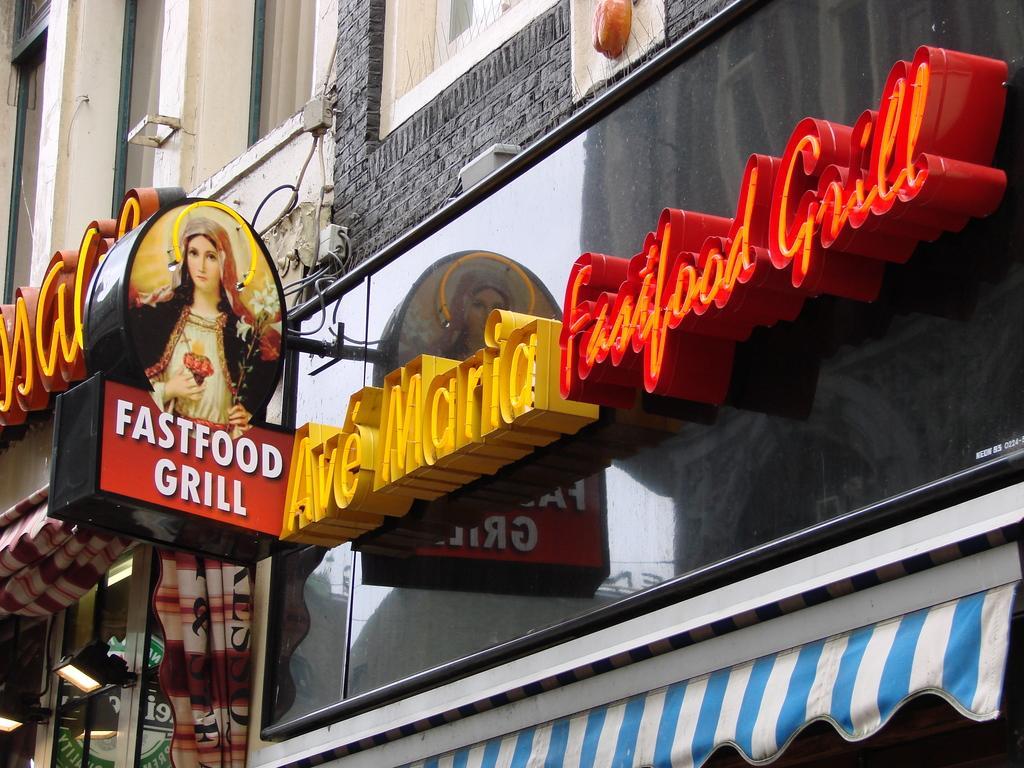Could you give a brief overview of what you see in this image? In this image there are two buildings with lights, light boards, a board with a photo of a person on it , name board. 